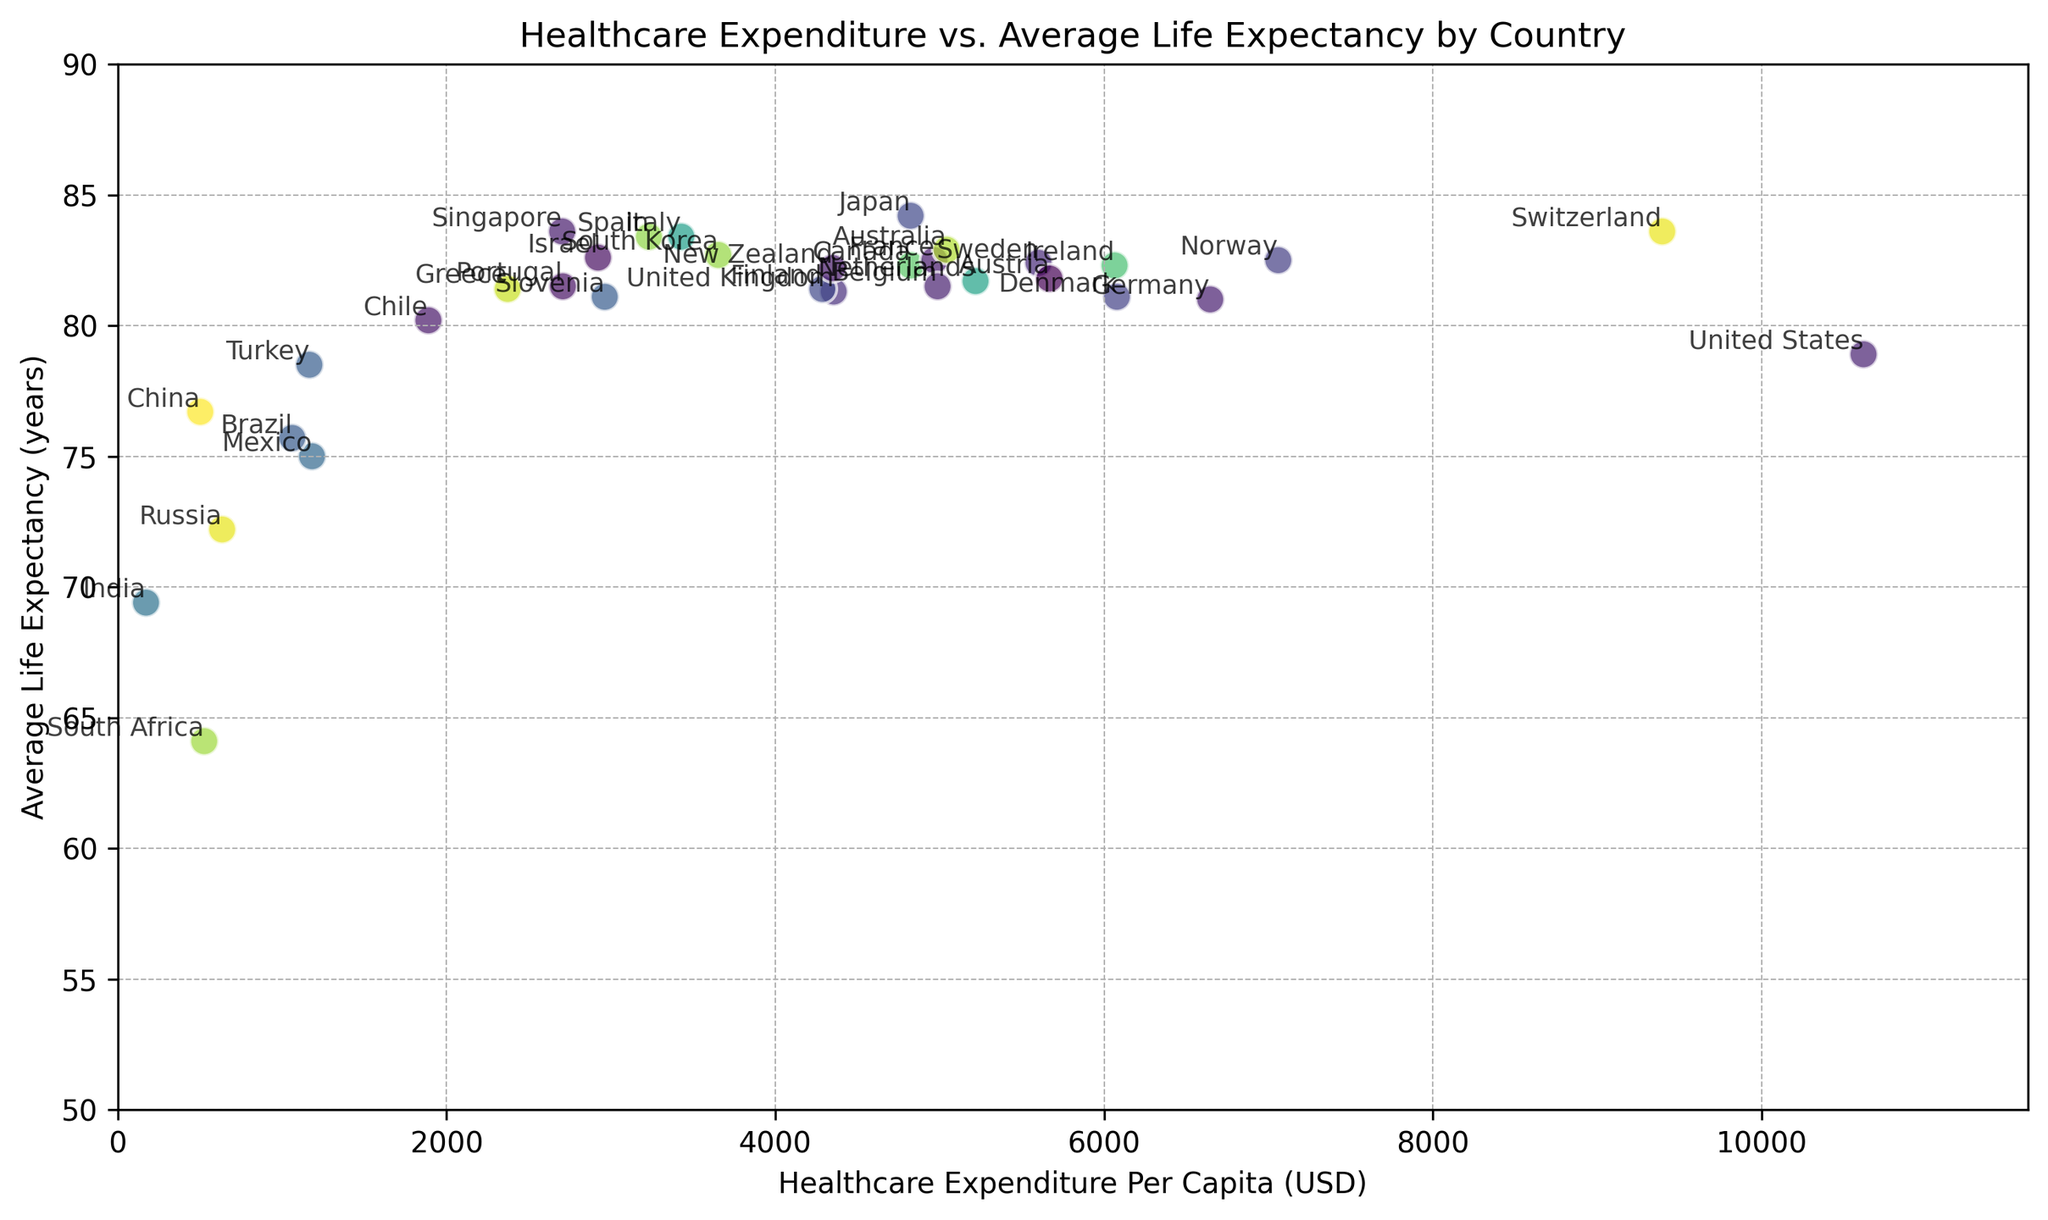What country has the highest healthcare expenditure per capita? Locate the point farthest to the right in the scatter plot. This point corresponds to the country with the highest healthcare expenditure per capita. In this case, it is the United States.
Answer: United States Which country has the lowest average life expectancy? Find the point with the lowest value on the y-axis (Average Life Expectancy). This point represents the country with the lowest average life expectancy. In this case, it is South Africa.
Answer: South Africa How does the healthcare expenditure per capita in Canada compare to that in Germany? Identify the points for Canada and Germany on the x-axis (Healthcare Expenditure Per Capita) and compare their positions. Canada’s expenditure is at 4824 USD, and Germany’s is at 6646 USD. Therefore, Germany's expenditure is higher.
Answer: Germany's expenditure is higher Is there a country with both lower healthcare expenditure per capita and higher average life expectancy than the United Kingdom? Compare the healthcare expenditure per capita and average life expectancy of countries below the UK’s expenditure value (4355 USD) but with higher life expectancy (81.3 years).
Countries:
- Italy: 3428 USD, 83.4 years
- Spain: 3231 USD, 83.4 years
- South Korea: 3653 USD, 82.7 years
- Israel: 2921 USD, 82.6 years
- Singapore: 2703 USD, 83.6 years
Therefore, these countries meet both criteria.
Answer: Yes, there are multiple countries (Italy, Spain, South Korea, Israel, Singapore) What is the difference in average life expectancy between Japan and China? Locate the points for Japan and China on the y-axis (Average Life Expectancy). Japan’s average life expectancy is 84.2 years, and China’s is 76.7 years. Subtract China’s value from Japan’s value.
Difference: 84.2 - 76.7 = 7.5
Answer: 7.5 years Which region (Europe or Asia) shows a higher variation in healthcare expenditure per capita based on the figure? Identify European countries (e.g., Germany, France, Italy) and Asian countries (e.g., Japan, South Korea, China) on the x-axis. Calculate the variance or observe the spread of the data points for each region. European countries show a wider range of expenditure values (from around 1000 USD to 9396 USD) compared to Asian countries (from around 171 USD to 4823 USD)
Answer: Europe Are there any countries with healthcare expenditure per capita below 2000 USD but average life expectancy above 78 years? Look at countries with healthcare expenditure below 2000 USD and find if any of them have an average life expectancy greater than 78 years. Chile (1889 USD, 80.2 years) fits this criteria.
Answer: Yes, Chile 